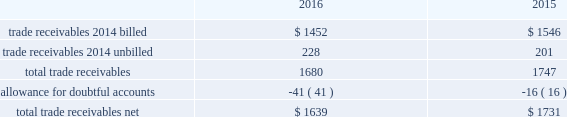Fidelity national information services , inc .
And subsidiaries notes to consolidated financial statements - ( continued ) contingent consideration liabilities recorded in connection with business acquisitions must also be adjusted for changes in fair value until settled .
See note 3 for discussion of the capital markets company bvba ( "capco" ) contingent consideration liability .
( d ) derivative financial instruments the company accounts for derivative financial instruments in accordance with financial accounting standards board accounting standards codification ( 201cfasb asc 201d ) topic 815 , derivatives and hedging .
During 2016 , 2015 and 2014 , the company engaged in g hedging activities relating to its variable rate debt through the use of interest rate swaps .
The company designates these interest rate swaps as cash flow hedges .
The estimated fair values of the cash flow hedges are determined using level 2 type measurements .
Thh ey are recorded as an asset or liability of the company and are included in the accompanying consolidated balance sheets in prepaid expenses and other current assets , other non-current assets , accounts payable and accrued liabilities or other long-term liabilities , as appropriate , and as a component of accumulated other comprehensive earnings , net of deferred taxes .
A portion of the amount included in accumulated other comprehensive earnings is recorded in interest expense as a yield adjustment as interest payments are made on then company 2019s term and revolving loans ( note 10 ) .
The company 2019s existing cash flow hedge is highly effective and there was no impact on 2016 earnings due to hedge ineffectiveness .
It is our policy to execute such instruments with credit-worthy banks and not to enter into derivative financial instruments for speculative purposes .
As of december 31 , 2016 , we believe that our interest rate swap counterparty will be able to fulfill its obligations under our agreement .
The company's foreign exchange risk management policy permits the use of derivative instruments , such as forward contracts and options , to reduce volatility in the company's results of operations and/or cash flows resulting from foreign exchange rate fluctuations .
During 2016 and 2015 , the company entered into foreign currency forward exchange contracts to hedge foreign currency exposure to intercompany loans .
As of december 31 , 2016 and 2015 , the notional amount of these derivatives was approximately $ 143 million and aa $ 81 million , respectively , and the fair value was nominal .
These derivatives have not been designated as hedges for accounting purposes .
We also use currency forward contracts to manage our exposure to fluctuations in costs caused by variations in indian rupee ( "inr" ) ii exchange rates .
As of december 31 , 2016 , the notional amount of these derivatives was approximately $ 7 million and the fair value was l less than $ 1 million , which is included in prepaid expenses and other current assets in the consolidated balance sheets .
These inr forward contracts are designated as cash flow hedges .
The fair value of these currency forward contracts is determined using currency uu exchange market rates , obtained from reliable , independent , third party banks , at the balance sheet date .
The fair value of forward rr contracts is subject to changes in currency exchange rates .
The company has no ineffectiveness related to its use of currency forward ff contracts in connection with inr cash flow hedges .
In september 2015 , the company entered into treasury lock hedges with a total notional amount of $ 1.0 billion , reducing the risk of changes in the benchmark index component of the 10-year treasury yield .
The company def signated these derivatives as cash flow hedges .
On october 13 , 2015 , in conjunction with the pricing of the $ 4.5 billion senior notes , the companyr terminated these treasury lock contracts for a cash settlement payment of $ 16 million , which was recorded as a component of other comprehensive earnings and will be reclassified as an adjustment to interest expense over the ten years during which the related interest payments that were hedged will be recognized in income .
( e ) trade receivables a summary of trade receivables , net , as of december 31 , 2016 and 2015 is as follows ( in millions ) : .

What is the percentage change in total trade receivables? 
Computations: ((1680 - 1747) / 1747)
Answer: -0.03835. 